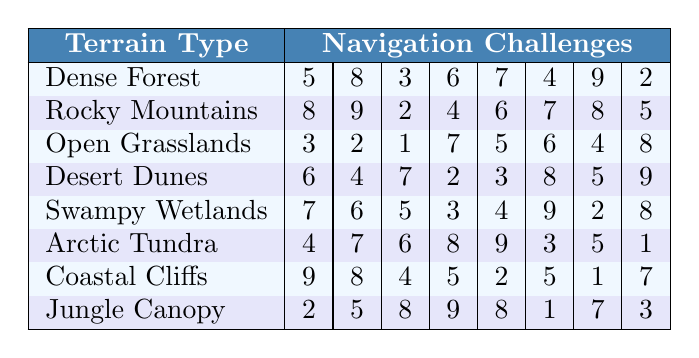What is the navigation challenge score for Dense Forest? The score for Dense Forest can be found in the first row of the table, which lists the challenges as [5, 8, 3, 6, 7, 4, 9, 2].
Answer: 5, 8, 3, 6, 7, 4, 9, 2 Which terrain type has the highest navigation challenge score? To find which terrain type has the highest navigation challenge score, we must look at each row and identify the maximum value. The highest score is 9 from Dense Forest and Coastal Cliffs.
Answer: Dense Forest and Coastal Cliffs What is the average navigation challenge score for Rocky Mountains? For Rocky Mountains, the scores are [8, 9, 2, 4, 6, 7, 8, 5]. There are 8 scores, so we sum them up (8 + 9 + 2 + 4 + 6 + 7 + 8 + 5 = 49) and divide by 8, giving an average of 49/8 = 6.125.
Answer: 6.125 Is Jungle Canopy's average navigation challenge score greater than 5? The scores for Jungle Canopy are [2, 5, 8, 9, 8, 1, 7, 3]. To find the average, we sum these scores (2 + 5 + 8 + 9 + 8 + 1 + 7 + 3 = 43) and divide by 8. The average is 43/8 = 5.375, which is greater than 5.
Answer: Yes What is the total of the navigation scores for Swampy Wetlands? The scores for Swampy Wetlands are [7, 6, 5, 3, 4, 9, 2, 8]. To find the total, we add these values together: 7 + 6 + 5 + 3 + 4 + 9 + 2 + 8 = 44.
Answer: 44 In which terrain type do you encounter the lowest single navigation challenge score? The lowest scores from each row are 2 (from Dense Forest), 2 (from Rocky Mountains), 1 (from Open Grasslands), 2 (from Desert Dunes), 2 (from Swampy Wetlands), 1 (from Arctic Tundra), 1 (from Coastal Cliffs), and 1 (from Jungle Canopy). The lowest score is therefore 1, found in Open Grasslands, Arctic Tundra, Coastal Cliffs, and Jungle Canopy.
Answer: Open Grasslands, Arctic Tundra, Coastal Cliffs, and Jungle Canopy What is the difference between the highest and lowest navigation challenge scores for Coastal Cliffs? For Coastal Cliffs, the scores are [9, 8, 4, 5, 2, 5, 1, 7]. The highest score is 9 and the lowest score is 1. The difference is calculated as 9 - 1 = 8.
Answer: 8 Which terrain types have navigation challenge scores that sum up to more than 40? Analyzing the sum of scores: Dense Forest (44), Rocky Mountains (49), Open Grasslands (42), Desert Dunes (44), Swampy Wetlands (44), Arctic Tundra (39), Coastal Cliffs (41), Jungle Canopy (43). The terrains that sum more than 40 are Dense Forest, Rocky Mountains, Open Grasslands, Desert Dunes, Swampy Wetlands, Coastal Cliffs, and Jungle Canopy.
Answer: Dense Forest, Rocky Mountains, Open Grasslands, Desert Dunes, Swampy Wetlands, Coastal Cliffs, and Jungle Canopy What is the median navigation challenge score for Arctic Tundra? The scores for Arctic Tundra are [4, 7, 6, 8, 9, 3, 5, 1]. To find the median, first arrange the scores in ascending order: [1, 3, 4, 5, 6, 7, 8, 9]. There are 8 scores, so the median will be the average of the 4th and 5th values: (5 + 6) / 2 = 5.5.
Answer: 5.5 